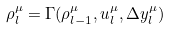<formula> <loc_0><loc_0><loc_500><loc_500>\rho ^ { \mu } _ { l } = \Gamma ( \rho ^ { \mu } _ { l - 1 } , u ^ { \mu } _ { l } , \Delta y ^ { \mu } _ { l } )</formula> 